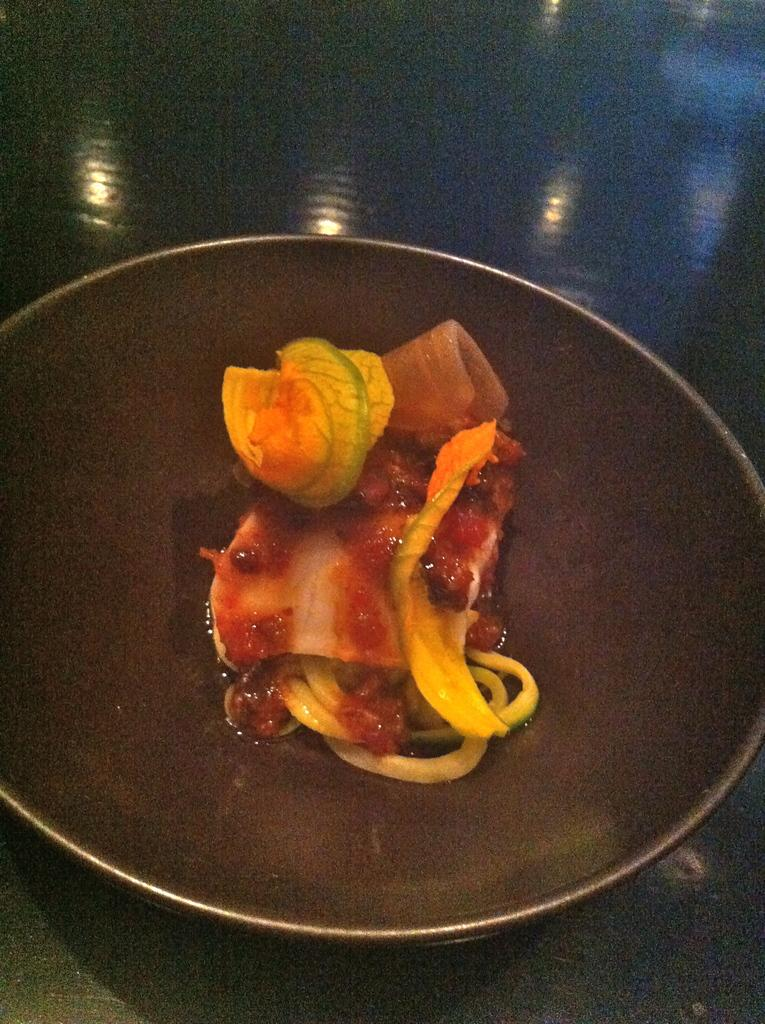What is the main object in the image? There is a dish in the image. Where is the dish located? The dish is in a pan. What is the pan placed on? The pan is placed on a table. What type of goat can be seen in the image? There is no goat present in the image. How is the brother related to the dish in the image? There is no brother mentioned or depicted in the image. 